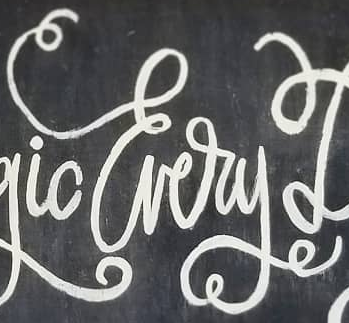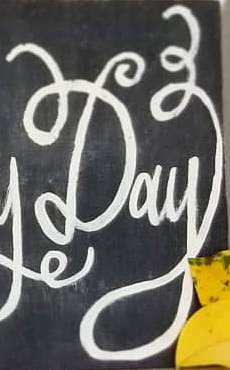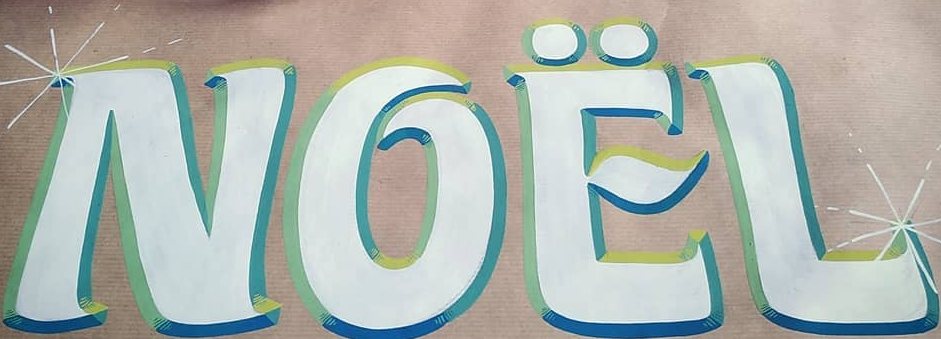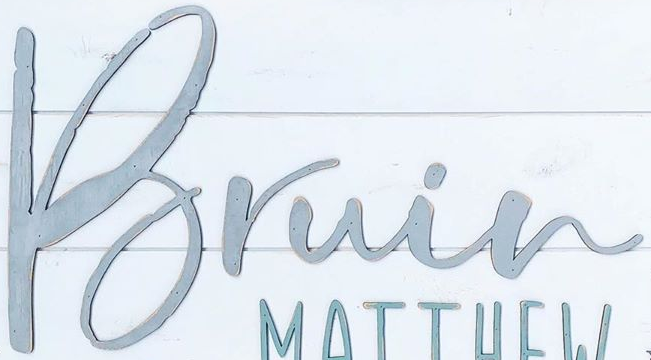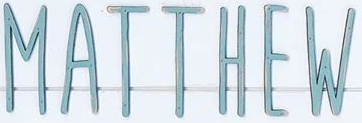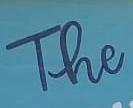Transcribe the words shown in these images in order, separated by a semicolon. Every; Day; NOËL; Bruin; MATTHEW; The 